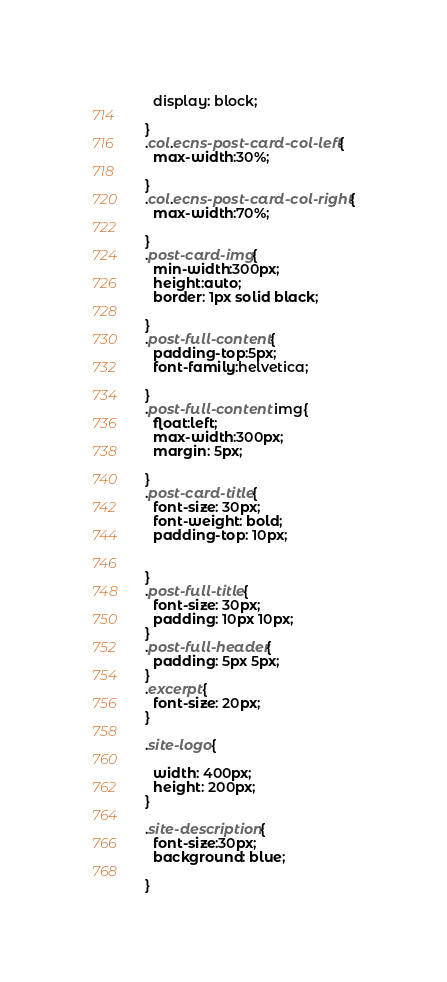Convert code to text. <code><loc_0><loc_0><loc_500><loc_500><_CSS_>  display: block;

}
.col.ecns-post-card-col-left{
  max-width:30%;

}
.col.ecns-post-card-col-right{
  max-width:70%;  

}
.post-card-img{
  min-width:300px;
  height:auto;
  border: 1px solid black;

}
.post-full-content{
  padding-top:5px;
  font-family:helvetica;

}
.post-full-content img{
  float:left;
  max-width:300px;
  margin: 5px;

}
.post-card-title{
  font-size: 30px;  
  font-weight: bold;
  padding-top: 10px;


}
.post-full-title{
  font-size: 30px;
  padding: 10px 10px;
}
.post-full-header{
  padding: 5px 5px;
}
.excerpt{
  font-size: 20px;
}

.site-logo{

  width: 400px;
  height: 200px;
}

.site-description{
  font-size:30px;
  background: blue;

}
</code> 